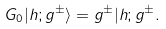<formula> <loc_0><loc_0><loc_500><loc_500>G _ { 0 } | h ; g ^ { \pm } \rangle = g ^ { \pm } | h ; g ^ { \pm } .</formula> 